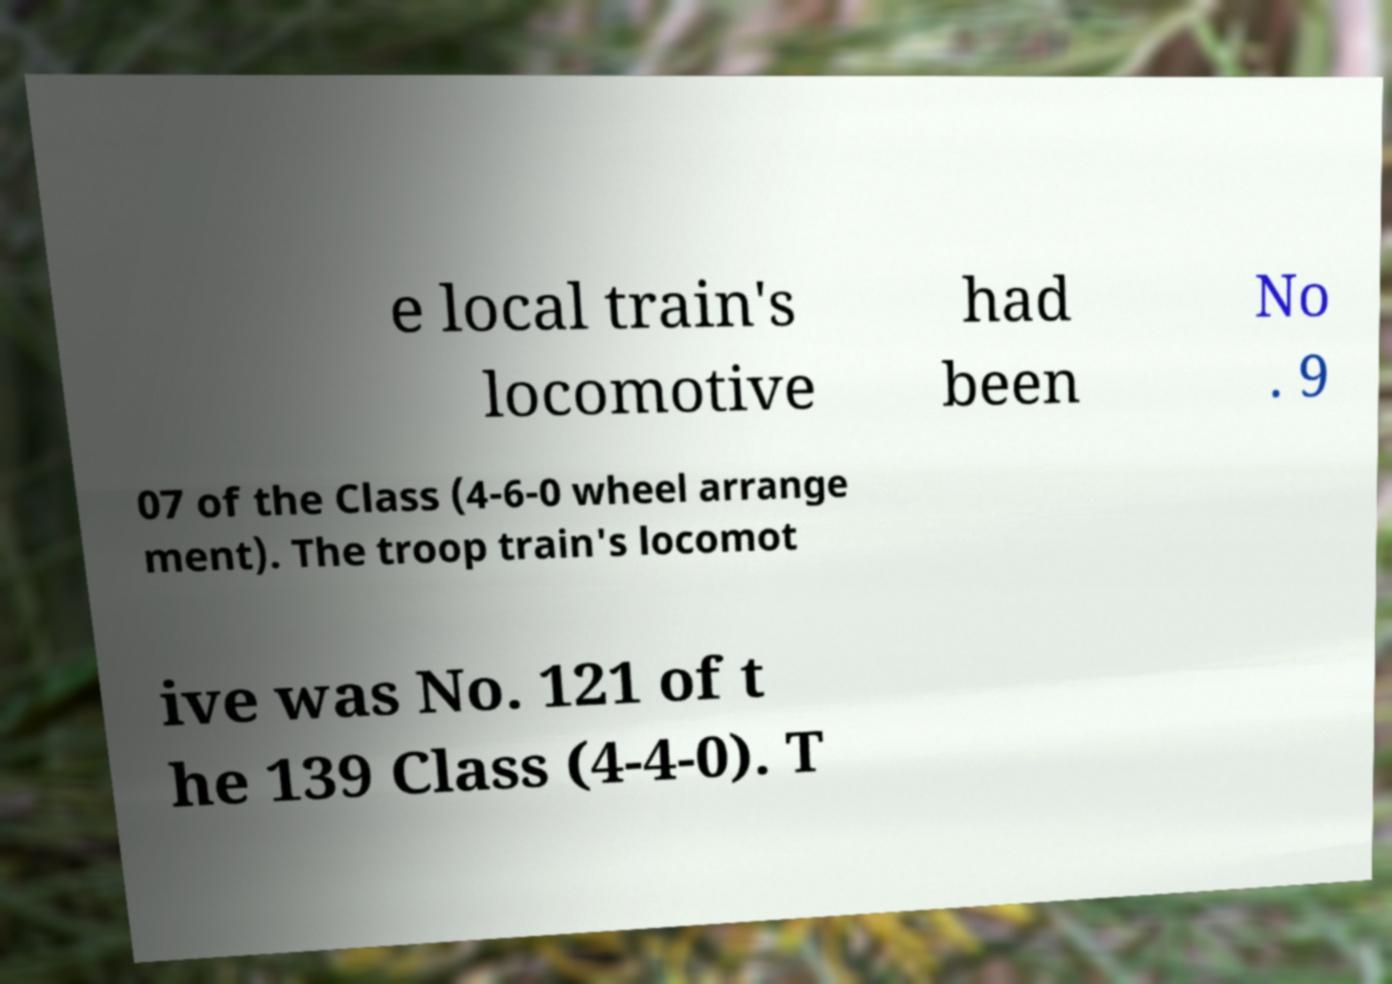What messages or text are displayed in this image? I need them in a readable, typed format. e local train's locomotive had been No . 9 07 of the Class (4-6-0 wheel arrange ment). The troop train's locomot ive was No. 121 of t he 139 Class (4-4-0). T 